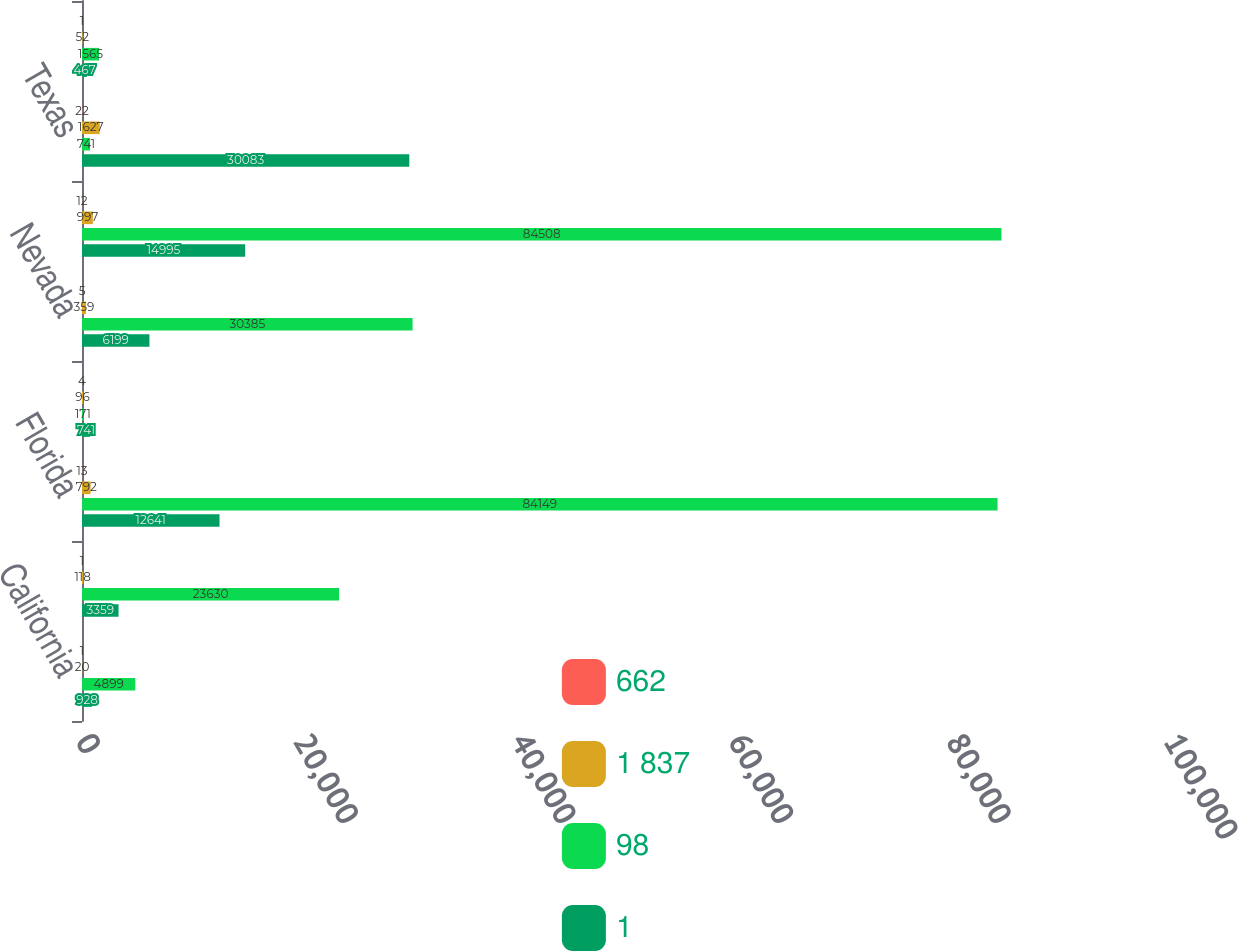Convert chart. <chart><loc_0><loc_0><loc_500><loc_500><stacked_bar_chart><ecel><fcel>California<fcel>Colorado<fcel>Florida<fcel>Louisiana<fcel>Nevada<fcel>Tennessee<fcel>Texas<fcel>Virginia<nl><fcel>662<fcel>1<fcel>1<fcel>13<fcel>4<fcel>5<fcel>12<fcel>22<fcel>1<nl><fcel>1 837<fcel>20<fcel>118<fcel>792<fcel>96<fcel>359<fcel>997<fcel>1627<fcel>52<nl><fcel>98<fcel>4899<fcel>23630<fcel>84149<fcel>171<fcel>30385<fcel>84508<fcel>741<fcel>1565<nl><fcel>1<fcel>928<fcel>3359<fcel>12641<fcel>741<fcel>6199<fcel>14995<fcel>30083<fcel>467<nl></chart> 